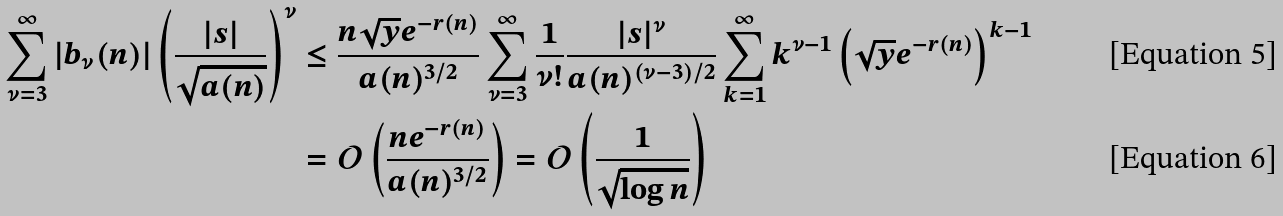<formula> <loc_0><loc_0><loc_500><loc_500>\sum _ { \nu = 3 } ^ { \infty } | b _ { \nu } ( n ) | \left ( \frac { | s | } { \sqrt { a ( n ) } } \right ) ^ { \nu } & \leq \frac { n \sqrt { y } e ^ { - r ( n ) } } { a ( n ) ^ { 3 / 2 } } \sum _ { \nu = 3 } ^ { \infty } \frac { 1 } { \nu ! } \frac { | s | ^ { \nu } } { a ( n ) ^ { ( \nu - 3 ) / 2 } } \sum _ { k = 1 } ^ { \infty } k ^ { \nu - 1 } \left ( \sqrt { y } e ^ { - r ( n ) } \right ) ^ { k - 1 } \\ & = \mathcal { O } \left ( \frac { n e ^ { - r ( n ) } } { a ( n ) ^ { 3 / 2 } } \right ) = \mathcal { O } \left ( \frac { 1 } { \sqrt { \log n } } \right )</formula> 